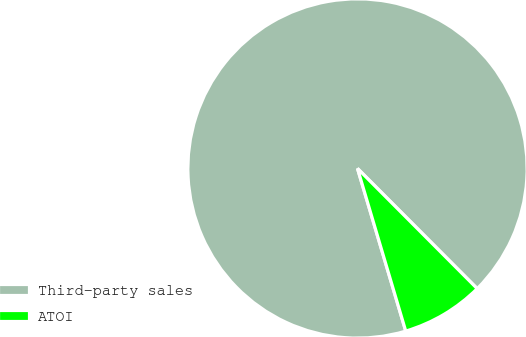<chart> <loc_0><loc_0><loc_500><loc_500><pie_chart><fcel>Third-party sales<fcel>ATOI<nl><fcel>92.12%<fcel>7.88%<nl></chart> 